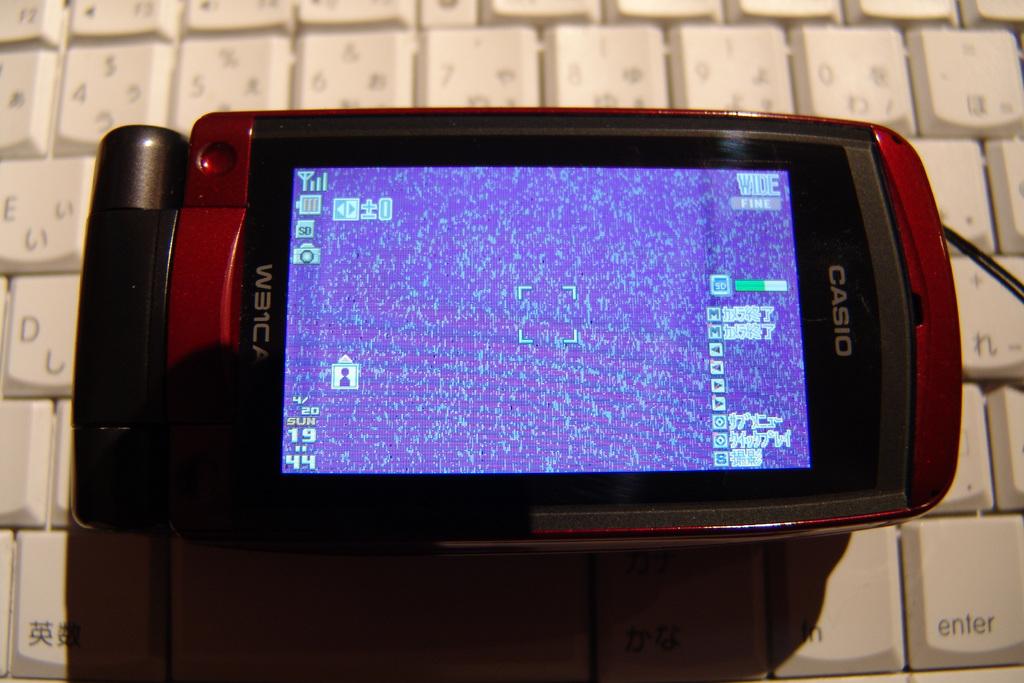What brand of phone is this?
Ensure brevity in your answer.  Casio. What does the key to the right say?
Your answer should be very brief. Enter. 